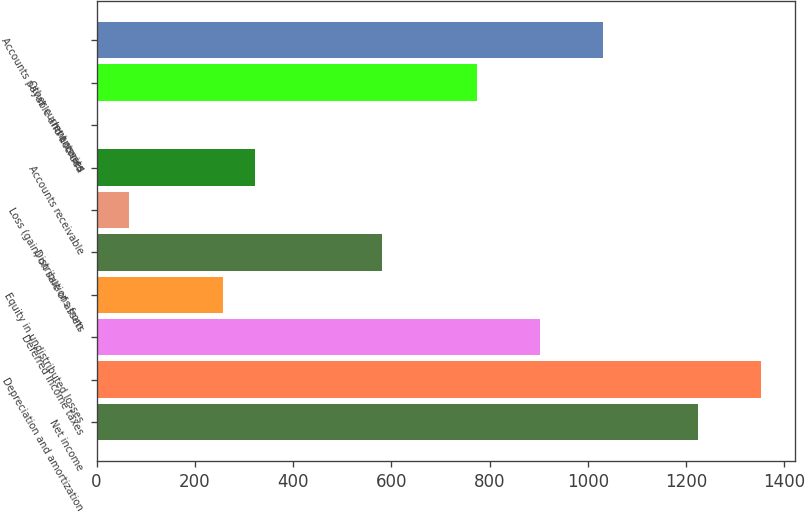Convert chart to OTSL. <chart><loc_0><loc_0><loc_500><loc_500><bar_chart><fcel>Net income<fcel>Depreciation and amortization<fcel>Deferred income taxes<fcel>Equity in undistributed losses<fcel>Distributions from<fcel>Loss (gain) on sale of assets<fcel>Accounts receivable<fcel>Inventories<fcel>Other current assets<fcel>Accounts payable and accrued<nl><fcel>1224.21<fcel>1352.99<fcel>902.26<fcel>258.36<fcel>580.31<fcel>65.19<fcel>322.75<fcel>0.8<fcel>773.48<fcel>1031.04<nl></chart> 